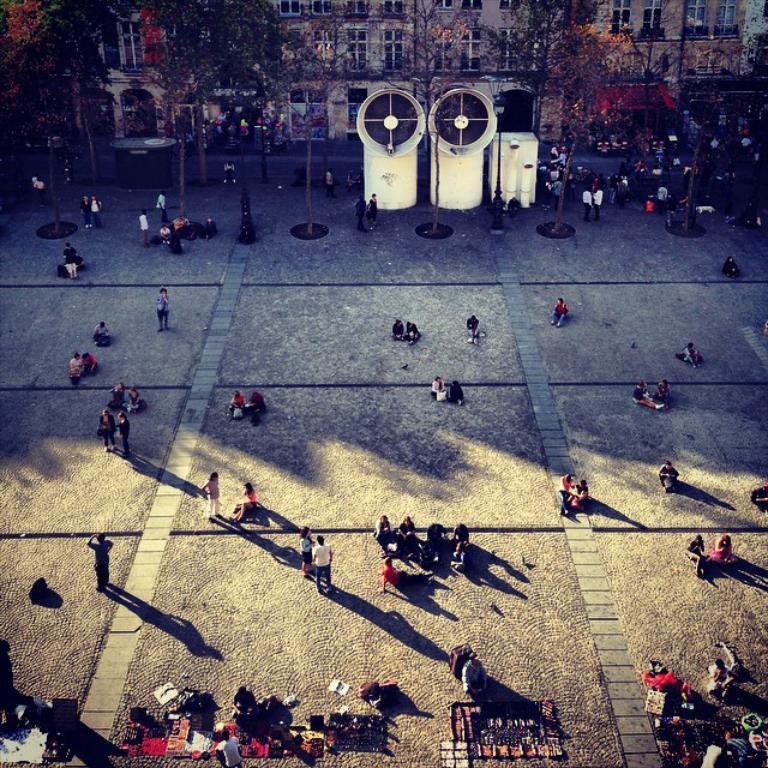What are the people in the image doing? Some people are standing, while others are seated in the image. What structures can be seen in the background? There are buildings visible in the image. What type of vegetation is present in the image? There are trees in the image. What objects can be seen on the ground? There are bags on the ground in the image. What type of smell can be detected in the image? There is no information about smells in the image, so it cannot be determined from the image. 